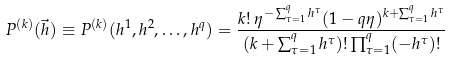Convert formula to latex. <formula><loc_0><loc_0><loc_500><loc_500>P ^ { ( k ) } ( \vec { h } ) \equiv P ^ { ( k ) } ( h ^ { 1 } , h ^ { 2 } , \dots , h ^ { q } ) = \frac { k ! \, \eta ^ { - \sum _ { \tau = 1 } ^ { q } h ^ { \tau } } ( 1 - q \eta ) ^ { k + \sum _ { \tau = 1 } ^ { q } h ^ { \tau } } } { ( k + \sum _ { \tau = 1 } ^ { q } h ^ { \tau } ) ! \prod _ { \tau = 1 } ^ { q } ( - h ^ { \tau } ) ! }</formula> 